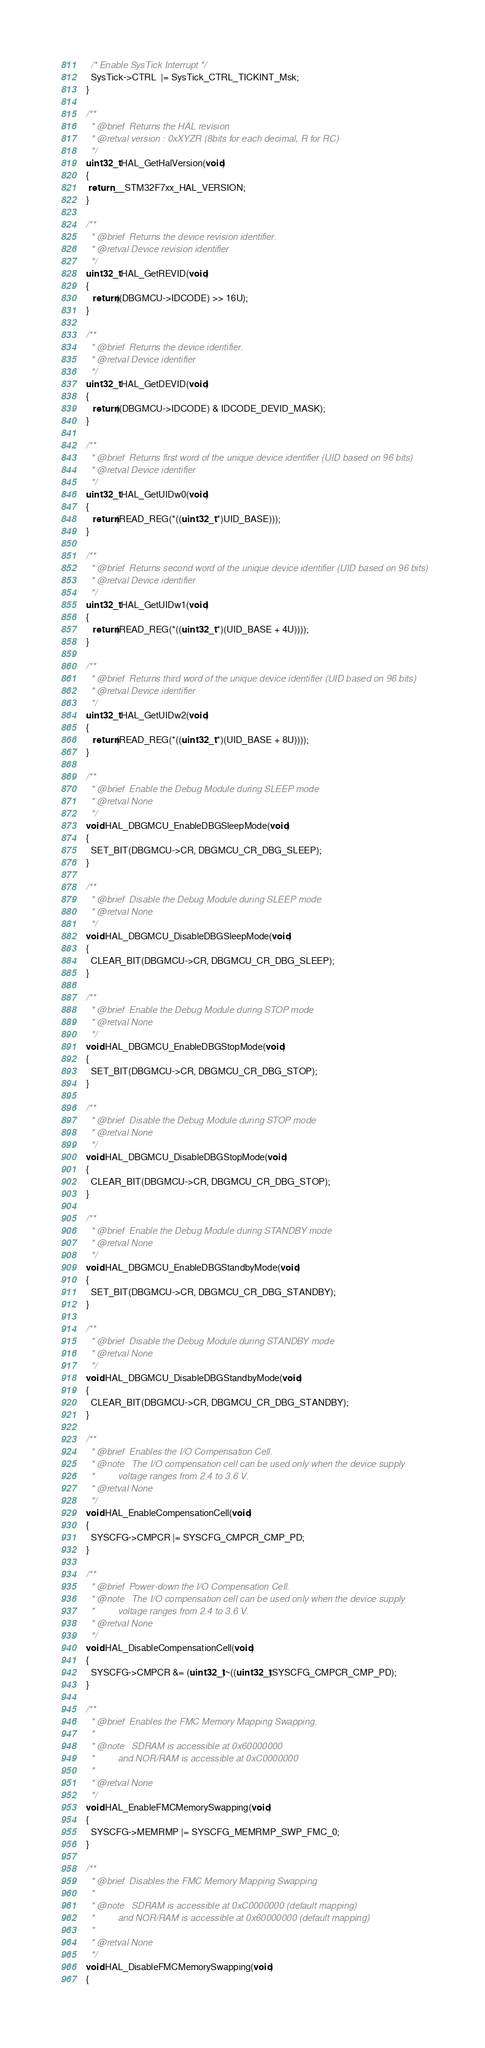<code> <loc_0><loc_0><loc_500><loc_500><_C_>  /* Enable SysTick Interrupt */
  SysTick->CTRL  |= SysTick_CTRL_TICKINT_Msk;
}

/**
  * @brief  Returns the HAL revision
  * @retval version : 0xXYZR (8bits for each decimal, R for RC)
  */
uint32_t HAL_GetHalVersion(void)
{
 return __STM32F7xx_HAL_VERSION;
}

/**
  * @brief  Returns the device revision identifier.
  * @retval Device revision identifier
  */
uint32_t HAL_GetREVID(void)
{
   return((DBGMCU->IDCODE) >> 16U);
}

/**
  * @brief  Returns the device identifier.
  * @retval Device identifier
  */
uint32_t HAL_GetDEVID(void)
{
   return((DBGMCU->IDCODE) & IDCODE_DEVID_MASK);
}

/**
  * @brief  Returns first word of the unique device identifier (UID based on 96 bits)
  * @retval Device identifier
  */
uint32_t HAL_GetUIDw0(void)
{
   return(READ_REG(*((uint32_t *)UID_BASE)));
}

/**
  * @brief  Returns second word of the unique device identifier (UID based on 96 bits)
  * @retval Device identifier
  */
uint32_t HAL_GetUIDw1(void)
{
   return(READ_REG(*((uint32_t *)(UID_BASE + 4U))));
}

/**
  * @brief  Returns third word of the unique device identifier (UID based on 96 bits)
  * @retval Device identifier
  */
uint32_t HAL_GetUIDw2(void)
{
   return(READ_REG(*((uint32_t *)(UID_BASE + 8U))));
}

/**
  * @brief  Enable the Debug Module during SLEEP mode
  * @retval None
  */
void HAL_DBGMCU_EnableDBGSleepMode(void)
{
  SET_BIT(DBGMCU->CR, DBGMCU_CR_DBG_SLEEP);
}

/**
  * @brief  Disable the Debug Module during SLEEP mode
  * @retval None
  */
void HAL_DBGMCU_DisableDBGSleepMode(void)
{
  CLEAR_BIT(DBGMCU->CR, DBGMCU_CR_DBG_SLEEP);
}

/**
  * @brief  Enable the Debug Module during STOP mode
  * @retval None
  */
void HAL_DBGMCU_EnableDBGStopMode(void)
{
  SET_BIT(DBGMCU->CR, DBGMCU_CR_DBG_STOP);
}

/**
  * @brief  Disable the Debug Module during STOP mode
  * @retval None
  */
void HAL_DBGMCU_DisableDBGStopMode(void)
{
  CLEAR_BIT(DBGMCU->CR, DBGMCU_CR_DBG_STOP);
}

/**
  * @brief  Enable the Debug Module during STANDBY mode
  * @retval None
  */
void HAL_DBGMCU_EnableDBGStandbyMode(void)
{
  SET_BIT(DBGMCU->CR, DBGMCU_CR_DBG_STANDBY);
}

/**
  * @brief  Disable the Debug Module during STANDBY mode
  * @retval None
  */
void HAL_DBGMCU_DisableDBGStandbyMode(void)
{
  CLEAR_BIT(DBGMCU->CR, DBGMCU_CR_DBG_STANDBY);
}

/**
  * @brief  Enables the I/O Compensation Cell.
  * @note   The I/O compensation cell can be used only when the device supply
  *         voltage ranges from 2.4 to 3.6 V.
  * @retval None
  */
void HAL_EnableCompensationCell(void)
{
  SYSCFG->CMPCR |= SYSCFG_CMPCR_CMP_PD;
}

/**
  * @brief  Power-down the I/O Compensation Cell.
  * @note   The I/O compensation cell can be used only when the device supply
  *         voltage ranges from 2.4 to 3.6 V.
  * @retval None
  */
void HAL_DisableCompensationCell(void)
{
  SYSCFG->CMPCR &= (uint32_t)~((uint32_t)SYSCFG_CMPCR_CMP_PD);
}

/**
  * @brief  Enables the FMC Memory Mapping Swapping.
  *
  * @note   SDRAM is accessible at 0x60000000
  *         and NOR/RAM is accessible at 0xC0000000
  *
  * @retval None
  */
void HAL_EnableFMCMemorySwapping(void)
{
  SYSCFG->MEMRMP |= SYSCFG_MEMRMP_SWP_FMC_0;
}

/**
  * @brief  Disables the FMC Memory Mapping Swapping
  *
  * @note   SDRAM is accessible at 0xC0000000 (default mapping)
  *         and NOR/RAM is accessible at 0x60000000 (default mapping)
  *
  * @retval None
  */
void HAL_DisableFMCMemorySwapping(void)
{
</code> 